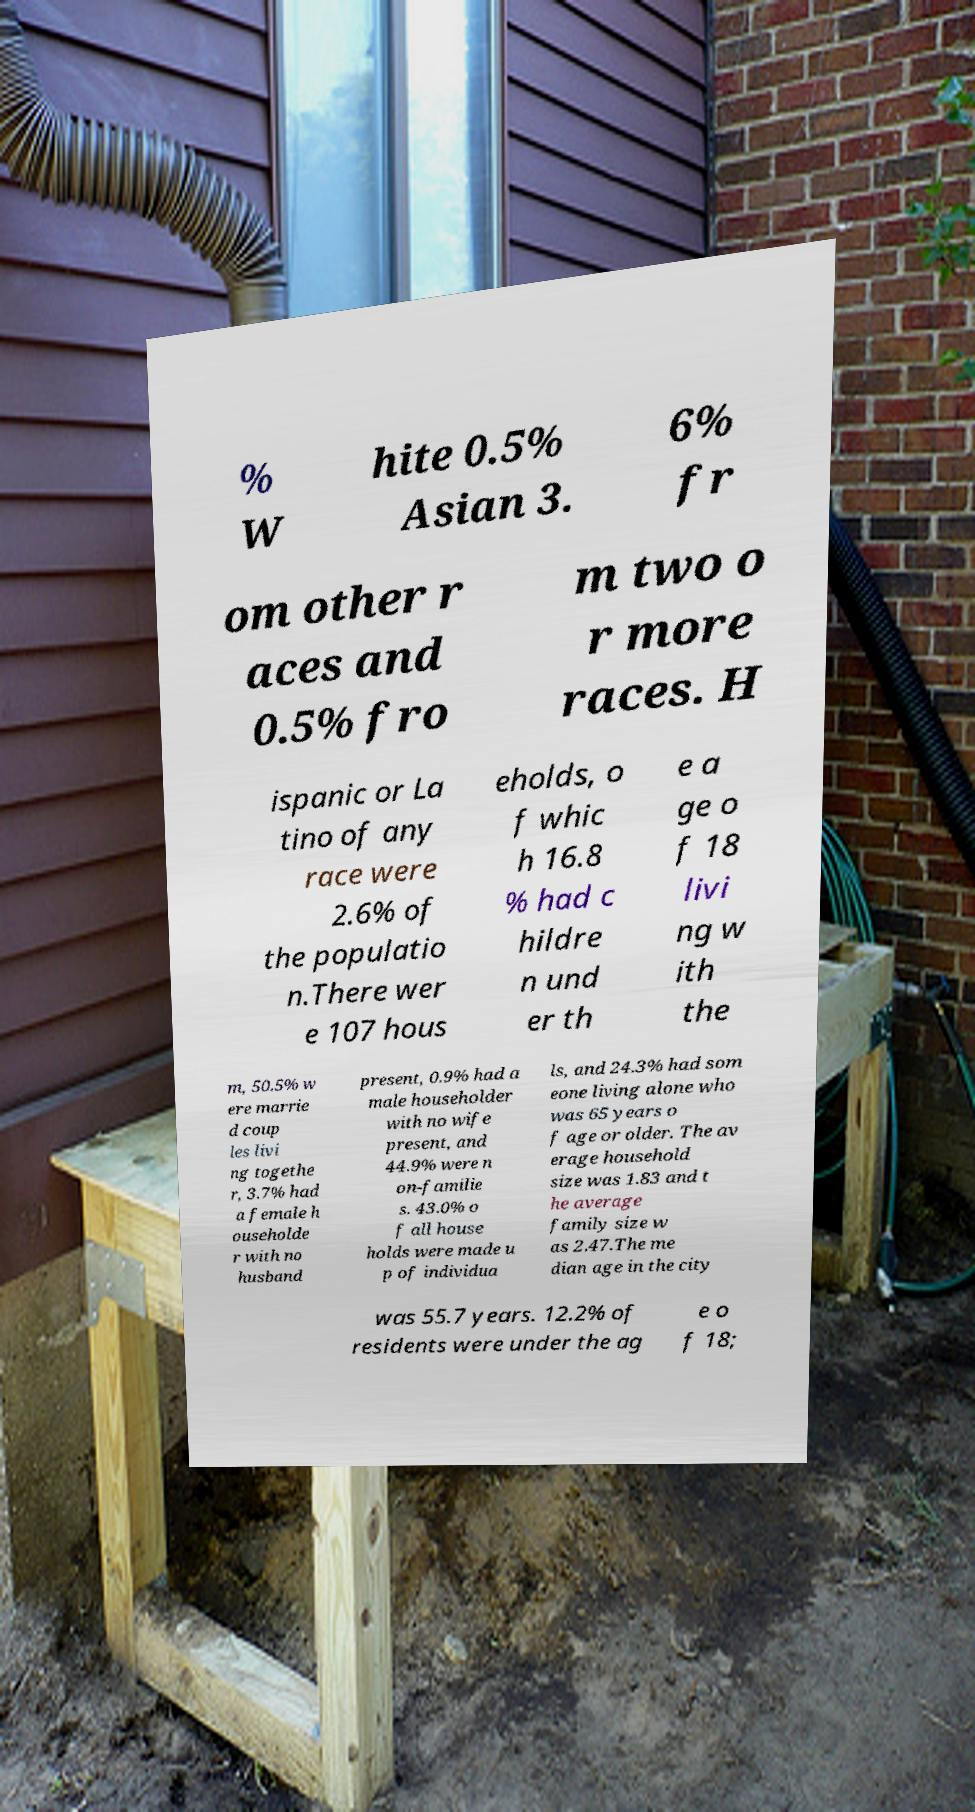Could you extract and type out the text from this image? % W hite 0.5% Asian 3. 6% fr om other r aces and 0.5% fro m two o r more races. H ispanic or La tino of any race were 2.6% of the populatio n.There wer e 107 hous eholds, o f whic h 16.8 % had c hildre n und er th e a ge o f 18 livi ng w ith the m, 50.5% w ere marrie d coup les livi ng togethe r, 3.7% had a female h ouseholde r with no husband present, 0.9% had a male householder with no wife present, and 44.9% were n on-familie s. 43.0% o f all house holds were made u p of individua ls, and 24.3% had som eone living alone who was 65 years o f age or older. The av erage household size was 1.83 and t he average family size w as 2.47.The me dian age in the city was 55.7 years. 12.2% of residents were under the ag e o f 18; 